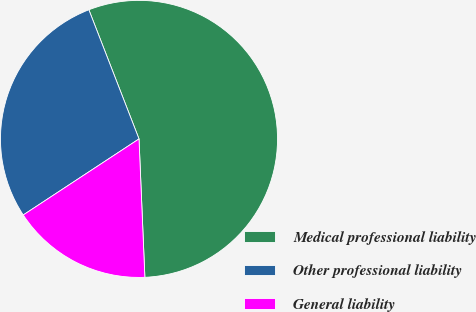<chart> <loc_0><loc_0><loc_500><loc_500><pie_chart><fcel>Medical professional liability<fcel>Other professional liability<fcel>General liability<nl><fcel>55.22%<fcel>28.36%<fcel>16.42%<nl></chart> 